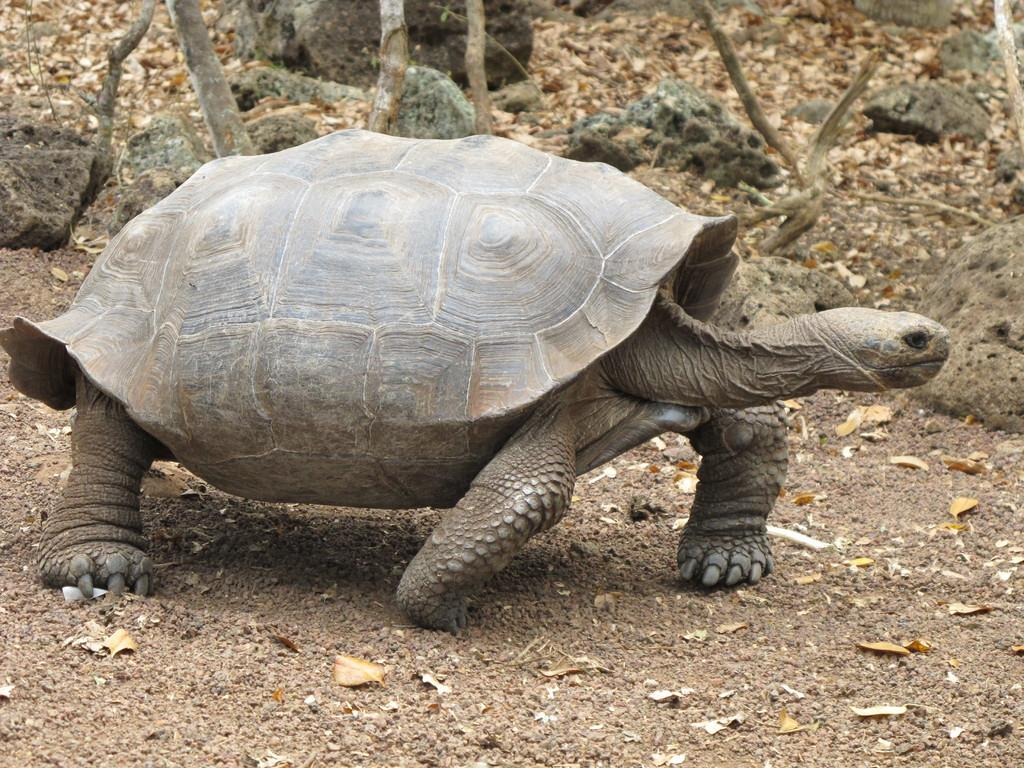What type of animal is on the path in the image? There is a tortoise on the path in the image. What can be seen on the ground in the image? There are stones and leaves on the ground in the image. Can you see a banana being used as a skateboard for the tortoise in the image? No, there is no banana or skateboard present in the image. 